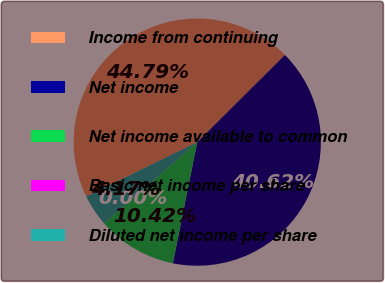Convert chart. <chart><loc_0><loc_0><loc_500><loc_500><pie_chart><fcel>Income from continuing<fcel>Net income<fcel>Net income available to common<fcel>Basic net income per share<fcel>Diluted net income per share<nl><fcel>44.79%<fcel>40.62%<fcel>10.42%<fcel>0.0%<fcel>4.17%<nl></chart> 